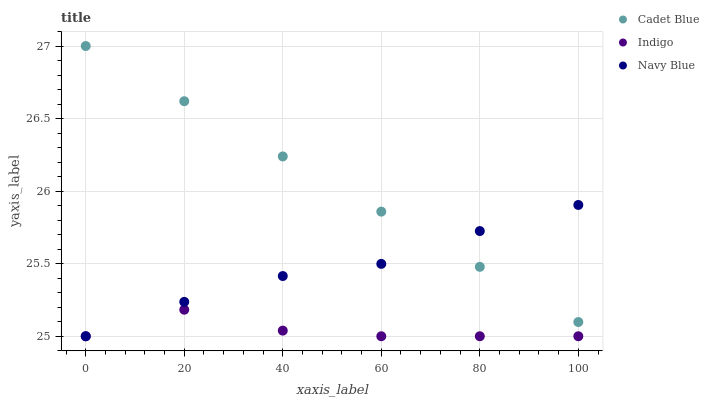Does Indigo have the minimum area under the curve?
Answer yes or no. Yes. Does Cadet Blue have the maximum area under the curve?
Answer yes or no. Yes. Does Cadet Blue have the minimum area under the curve?
Answer yes or no. No. Does Indigo have the maximum area under the curve?
Answer yes or no. No. Is Cadet Blue the smoothest?
Answer yes or no. Yes. Is Indigo the roughest?
Answer yes or no. Yes. Is Indigo the smoothest?
Answer yes or no. No. Is Cadet Blue the roughest?
Answer yes or no. No. Does Navy Blue have the lowest value?
Answer yes or no. Yes. Does Cadet Blue have the lowest value?
Answer yes or no. No. Does Cadet Blue have the highest value?
Answer yes or no. Yes. Does Indigo have the highest value?
Answer yes or no. No. Is Indigo less than Cadet Blue?
Answer yes or no. Yes. Is Cadet Blue greater than Indigo?
Answer yes or no. Yes. Does Indigo intersect Navy Blue?
Answer yes or no. Yes. Is Indigo less than Navy Blue?
Answer yes or no. No. Is Indigo greater than Navy Blue?
Answer yes or no. No. Does Indigo intersect Cadet Blue?
Answer yes or no. No. 